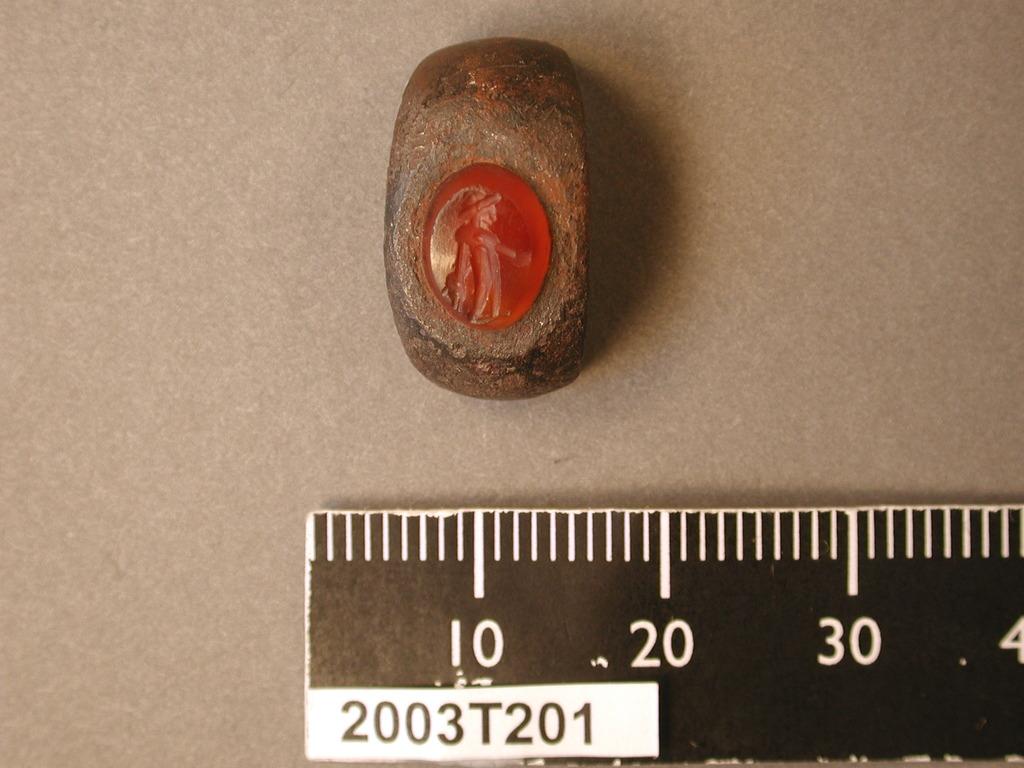What letter is directly under 10?
Your answer should be compact. T. 